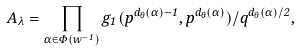Convert formula to latex. <formula><loc_0><loc_0><loc_500><loc_500>A _ { \lambda } = \prod _ { \alpha \in \Phi ( w ^ { - 1 } ) } g _ { 1 } ( p ^ { d _ { \theta } ( \alpha ) - 1 } , p ^ { d _ { \theta } ( \alpha ) } ) / q ^ { d _ { \theta } ( \alpha ) / 2 } ,</formula> 